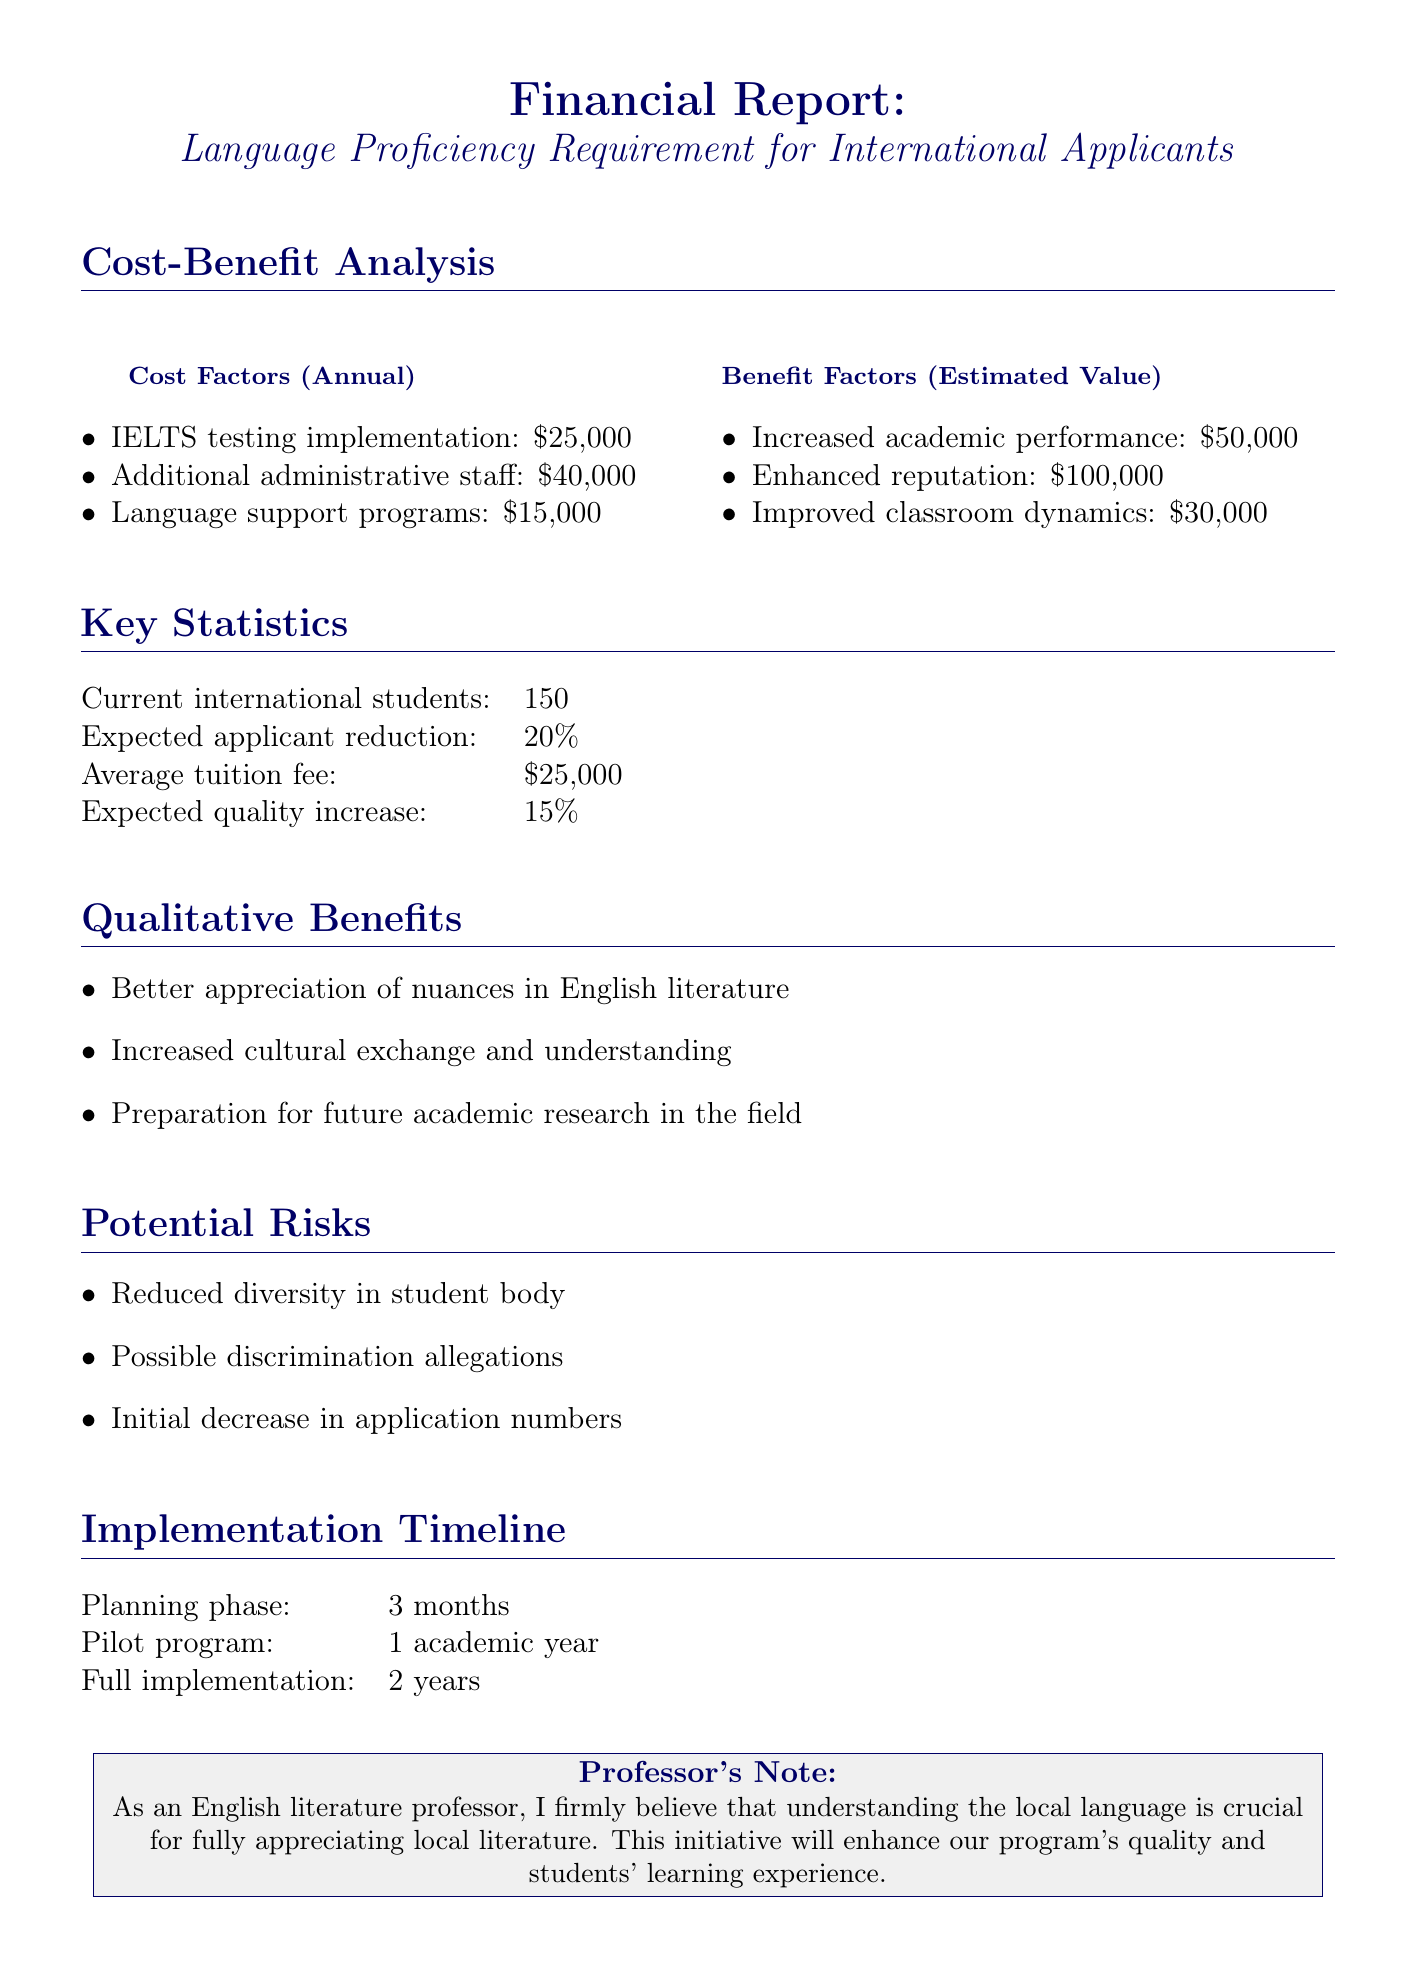What is the annual cost of IELTS testing? The annual cost of IELTS testing is specified in the document under cost factors.
Answer: $25,000 What is the expected applicant reduction percentage? The document provides the expected applicant reduction percentage in key statistics.
Answer: 20% What is the estimated value of enhanced reputation? The estimated value of enhanced reputation can be found in the benefit factors section of the document.
Answer: $100,000 What is one of the qualitative benefits mentioned? The document lists qualitative benefits, and one of them can be found in that section.
Answer: Better appreciation of nuances in English literature What is the planning phase duration for implementation? The implementation timeline specifies the duration of the planning phase.
Answer: 3 months What is the total annual cost of language support programs? The annual cost for language support programs is included in the cost factors.
Answer: $15,000 What is the timeline for the full implementation phase? The timeline for full implementation is included under the implementation timeline section.
Answer: 2 years What percentage increase in quality is expected? The expected quality increase percentage is stated in the key statistics.
Answer: 15% What potential risk is associated with reduced diversity? The document mentions a specific potential risk related to diversity.
Answer: Reduced diversity in student body 